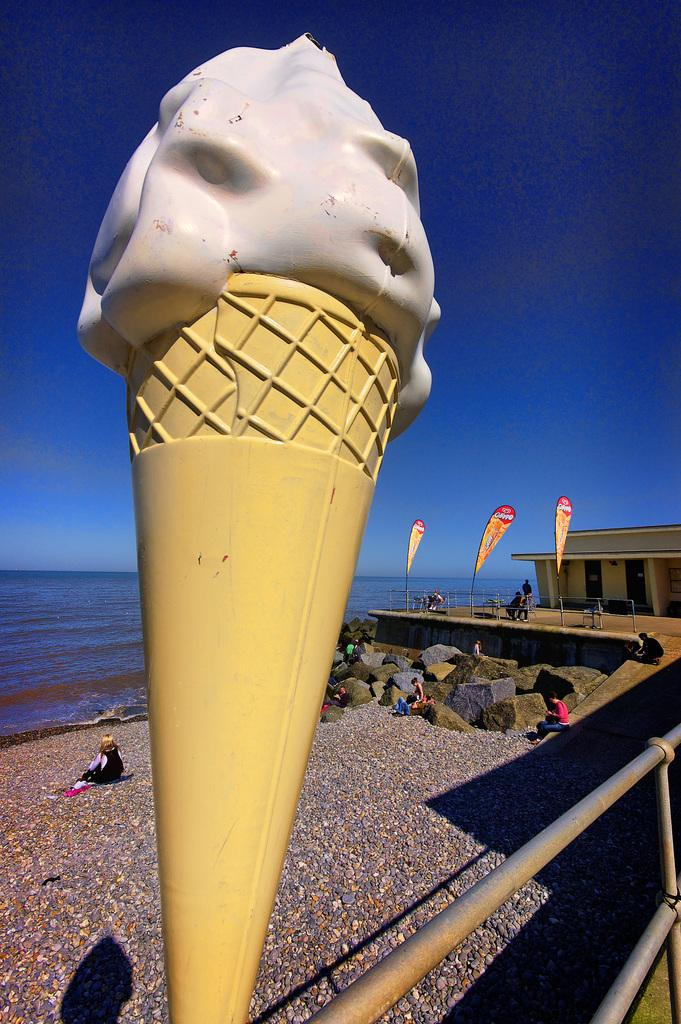What is the main subject of the image? There is a statue of an ice cream in the image. What can be seen in the background of the image? In the background, there are people, stones, a house, water, banners, and the sky. Can you describe the setting of the image? The image appears to be set outdoors, with a statue of an ice cream in the foreground and various elements in the background. What is the purpose of the rods on the right side bottom of the image? The purpose of the rods is not clear from the image, but they could be part of the statue's base or a separate element in the scene. What type of card is being handed out to people in the image? There is no card being handed out to people in the image. Is there a road visible in the image? No, there is no road visible in the image. What parcel is being delivered to the house in the background? There is no parcel being delivered to the house in the image. 